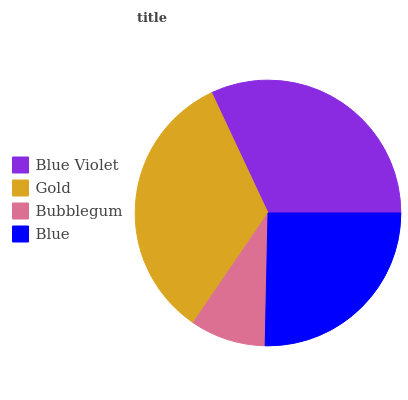Is Bubblegum the minimum?
Answer yes or no. Yes. Is Gold the maximum?
Answer yes or no. Yes. Is Gold the minimum?
Answer yes or no. No. Is Bubblegum the maximum?
Answer yes or no. No. Is Gold greater than Bubblegum?
Answer yes or no. Yes. Is Bubblegum less than Gold?
Answer yes or no. Yes. Is Bubblegum greater than Gold?
Answer yes or no. No. Is Gold less than Bubblegum?
Answer yes or no. No. Is Blue Violet the high median?
Answer yes or no. Yes. Is Blue the low median?
Answer yes or no. Yes. Is Gold the high median?
Answer yes or no. No. Is Blue Violet the low median?
Answer yes or no. No. 